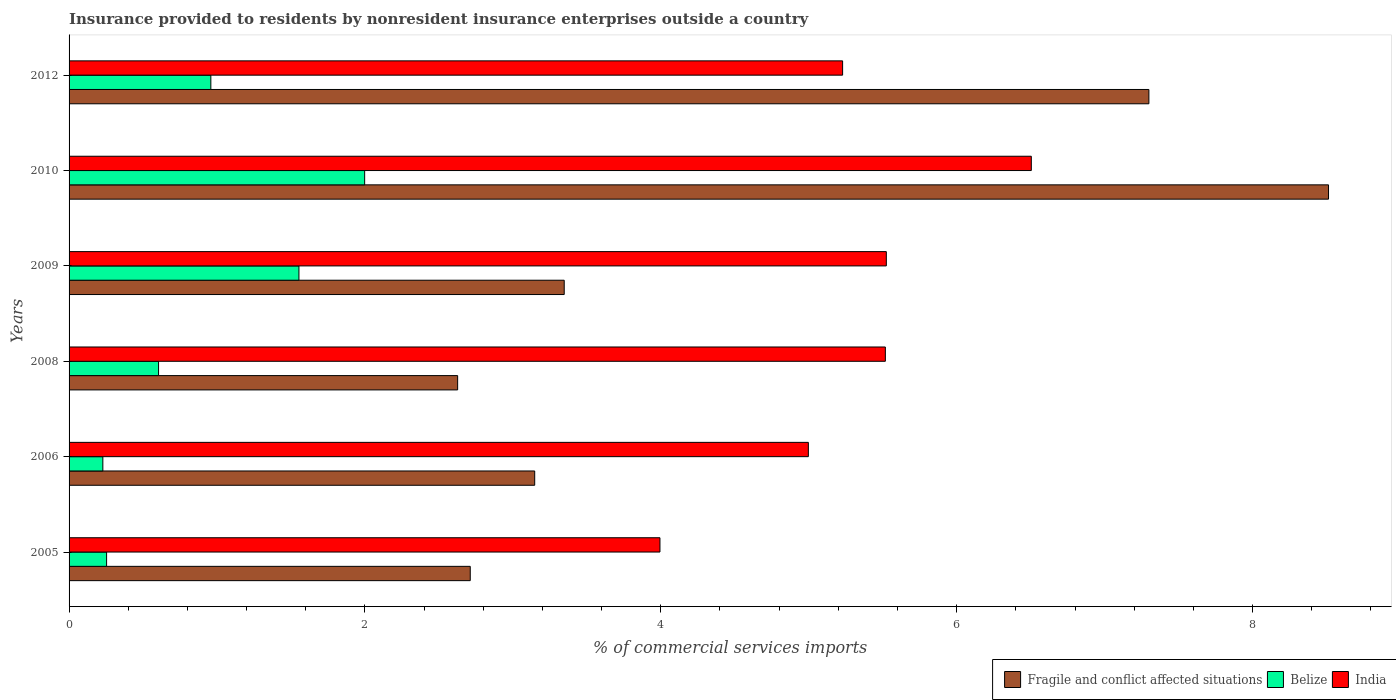How many different coloured bars are there?
Ensure brevity in your answer.  3. Are the number of bars per tick equal to the number of legend labels?
Provide a succinct answer. Yes. Are the number of bars on each tick of the Y-axis equal?
Give a very brief answer. Yes. How many bars are there on the 6th tick from the bottom?
Offer a very short reply. 3. In how many cases, is the number of bars for a given year not equal to the number of legend labels?
Your response must be concise. 0. What is the Insurance provided to residents in India in 2006?
Offer a terse response. 5. Across all years, what is the maximum Insurance provided to residents in Belize?
Provide a short and direct response. 2. Across all years, what is the minimum Insurance provided to residents in Belize?
Ensure brevity in your answer.  0.23. In which year was the Insurance provided to residents in Fragile and conflict affected situations minimum?
Offer a terse response. 2008. What is the total Insurance provided to residents in Belize in the graph?
Your response must be concise. 5.6. What is the difference between the Insurance provided to residents in Fragile and conflict affected situations in 2005 and that in 2012?
Ensure brevity in your answer.  -4.59. What is the difference between the Insurance provided to residents in Belize in 2006 and the Insurance provided to residents in India in 2012?
Make the answer very short. -5. What is the average Insurance provided to residents in India per year?
Provide a short and direct response. 5.29. In the year 2005, what is the difference between the Insurance provided to residents in Belize and Insurance provided to residents in Fragile and conflict affected situations?
Keep it short and to the point. -2.46. In how many years, is the Insurance provided to residents in India greater than 2 %?
Offer a very short reply. 6. What is the ratio of the Insurance provided to residents in India in 2005 to that in 2012?
Your response must be concise. 0.76. What is the difference between the highest and the second highest Insurance provided to residents in India?
Provide a succinct answer. 0.98. What is the difference between the highest and the lowest Insurance provided to residents in Belize?
Your answer should be very brief. 1.77. What does the 3rd bar from the top in 2006 represents?
Give a very brief answer. Fragile and conflict affected situations. What does the 3rd bar from the bottom in 2008 represents?
Provide a short and direct response. India. How many bars are there?
Offer a terse response. 18. Are all the bars in the graph horizontal?
Offer a terse response. Yes. What is the difference between two consecutive major ticks on the X-axis?
Give a very brief answer. 2. Where does the legend appear in the graph?
Give a very brief answer. Bottom right. How many legend labels are there?
Provide a succinct answer. 3. How are the legend labels stacked?
Offer a terse response. Horizontal. What is the title of the graph?
Your response must be concise. Insurance provided to residents by nonresident insurance enterprises outside a country. Does "Saudi Arabia" appear as one of the legend labels in the graph?
Your answer should be very brief. No. What is the label or title of the X-axis?
Keep it short and to the point. % of commercial services imports. What is the label or title of the Y-axis?
Ensure brevity in your answer.  Years. What is the % of commercial services imports of Fragile and conflict affected situations in 2005?
Ensure brevity in your answer.  2.71. What is the % of commercial services imports of Belize in 2005?
Offer a very short reply. 0.25. What is the % of commercial services imports in India in 2005?
Offer a very short reply. 3.99. What is the % of commercial services imports in Fragile and conflict affected situations in 2006?
Your answer should be very brief. 3.15. What is the % of commercial services imports of Belize in 2006?
Provide a succinct answer. 0.23. What is the % of commercial services imports of India in 2006?
Make the answer very short. 5. What is the % of commercial services imports of Fragile and conflict affected situations in 2008?
Keep it short and to the point. 2.63. What is the % of commercial services imports of Belize in 2008?
Offer a terse response. 0.6. What is the % of commercial services imports of India in 2008?
Ensure brevity in your answer.  5.52. What is the % of commercial services imports of Fragile and conflict affected situations in 2009?
Give a very brief answer. 3.35. What is the % of commercial services imports in Belize in 2009?
Your response must be concise. 1.55. What is the % of commercial services imports in India in 2009?
Keep it short and to the point. 5.52. What is the % of commercial services imports in Fragile and conflict affected situations in 2010?
Keep it short and to the point. 8.51. What is the % of commercial services imports in Belize in 2010?
Offer a very short reply. 2. What is the % of commercial services imports in India in 2010?
Keep it short and to the point. 6.5. What is the % of commercial services imports in Fragile and conflict affected situations in 2012?
Give a very brief answer. 7.3. What is the % of commercial services imports of Belize in 2012?
Your answer should be compact. 0.96. What is the % of commercial services imports in India in 2012?
Offer a very short reply. 5.23. Across all years, what is the maximum % of commercial services imports of Fragile and conflict affected situations?
Make the answer very short. 8.51. Across all years, what is the maximum % of commercial services imports in Belize?
Make the answer very short. 2. Across all years, what is the maximum % of commercial services imports of India?
Make the answer very short. 6.5. Across all years, what is the minimum % of commercial services imports of Fragile and conflict affected situations?
Give a very brief answer. 2.63. Across all years, what is the minimum % of commercial services imports in Belize?
Keep it short and to the point. 0.23. Across all years, what is the minimum % of commercial services imports of India?
Your answer should be very brief. 3.99. What is the total % of commercial services imports of Fragile and conflict affected situations in the graph?
Make the answer very short. 27.65. What is the total % of commercial services imports in Belize in the graph?
Your answer should be compact. 5.6. What is the total % of commercial services imports in India in the graph?
Provide a short and direct response. 31.77. What is the difference between the % of commercial services imports of Fragile and conflict affected situations in 2005 and that in 2006?
Your answer should be compact. -0.44. What is the difference between the % of commercial services imports of Belize in 2005 and that in 2006?
Ensure brevity in your answer.  0.03. What is the difference between the % of commercial services imports of India in 2005 and that in 2006?
Offer a very short reply. -1. What is the difference between the % of commercial services imports of Fragile and conflict affected situations in 2005 and that in 2008?
Your answer should be very brief. 0.09. What is the difference between the % of commercial services imports in Belize in 2005 and that in 2008?
Provide a short and direct response. -0.35. What is the difference between the % of commercial services imports in India in 2005 and that in 2008?
Offer a terse response. -1.52. What is the difference between the % of commercial services imports in Fragile and conflict affected situations in 2005 and that in 2009?
Your answer should be compact. -0.64. What is the difference between the % of commercial services imports in Belize in 2005 and that in 2009?
Provide a succinct answer. -1.3. What is the difference between the % of commercial services imports of India in 2005 and that in 2009?
Provide a short and direct response. -1.53. What is the difference between the % of commercial services imports in Fragile and conflict affected situations in 2005 and that in 2010?
Your answer should be compact. -5.8. What is the difference between the % of commercial services imports of Belize in 2005 and that in 2010?
Your answer should be compact. -1.74. What is the difference between the % of commercial services imports of India in 2005 and that in 2010?
Your answer should be compact. -2.51. What is the difference between the % of commercial services imports in Fragile and conflict affected situations in 2005 and that in 2012?
Offer a terse response. -4.59. What is the difference between the % of commercial services imports of Belize in 2005 and that in 2012?
Keep it short and to the point. -0.7. What is the difference between the % of commercial services imports in India in 2005 and that in 2012?
Keep it short and to the point. -1.23. What is the difference between the % of commercial services imports of Fragile and conflict affected situations in 2006 and that in 2008?
Keep it short and to the point. 0.52. What is the difference between the % of commercial services imports of Belize in 2006 and that in 2008?
Give a very brief answer. -0.38. What is the difference between the % of commercial services imports in India in 2006 and that in 2008?
Make the answer very short. -0.52. What is the difference between the % of commercial services imports in Fragile and conflict affected situations in 2006 and that in 2009?
Your answer should be compact. -0.2. What is the difference between the % of commercial services imports in Belize in 2006 and that in 2009?
Offer a terse response. -1.33. What is the difference between the % of commercial services imports of India in 2006 and that in 2009?
Offer a terse response. -0.53. What is the difference between the % of commercial services imports in Fragile and conflict affected situations in 2006 and that in 2010?
Your response must be concise. -5.37. What is the difference between the % of commercial services imports in Belize in 2006 and that in 2010?
Provide a short and direct response. -1.77. What is the difference between the % of commercial services imports in India in 2006 and that in 2010?
Your response must be concise. -1.51. What is the difference between the % of commercial services imports in Fragile and conflict affected situations in 2006 and that in 2012?
Your answer should be compact. -4.15. What is the difference between the % of commercial services imports of Belize in 2006 and that in 2012?
Offer a very short reply. -0.73. What is the difference between the % of commercial services imports of India in 2006 and that in 2012?
Your answer should be very brief. -0.23. What is the difference between the % of commercial services imports in Fragile and conflict affected situations in 2008 and that in 2009?
Offer a very short reply. -0.72. What is the difference between the % of commercial services imports in Belize in 2008 and that in 2009?
Your response must be concise. -0.95. What is the difference between the % of commercial services imports of India in 2008 and that in 2009?
Keep it short and to the point. -0.01. What is the difference between the % of commercial services imports of Fragile and conflict affected situations in 2008 and that in 2010?
Provide a succinct answer. -5.89. What is the difference between the % of commercial services imports of Belize in 2008 and that in 2010?
Provide a succinct answer. -1.39. What is the difference between the % of commercial services imports of India in 2008 and that in 2010?
Provide a short and direct response. -0.99. What is the difference between the % of commercial services imports of Fragile and conflict affected situations in 2008 and that in 2012?
Make the answer very short. -4.67. What is the difference between the % of commercial services imports in Belize in 2008 and that in 2012?
Ensure brevity in your answer.  -0.35. What is the difference between the % of commercial services imports in India in 2008 and that in 2012?
Provide a succinct answer. 0.29. What is the difference between the % of commercial services imports of Fragile and conflict affected situations in 2009 and that in 2010?
Your response must be concise. -5.17. What is the difference between the % of commercial services imports of Belize in 2009 and that in 2010?
Your response must be concise. -0.44. What is the difference between the % of commercial services imports of India in 2009 and that in 2010?
Offer a very short reply. -0.98. What is the difference between the % of commercial services imports of Fragile and conflict affected situations in 2009 and that in 2012?
Your answer should be very brief. -3.95. What is the difference between the % of commercial services imports in Belize in 2009 and that in 2012?
Your answer should be very brief. 0.6. What is the difference between the % of commercial services imports of India in 2009 and that in 2012?
Offer a terse response. 0.3. What is the difference between the % of commercial services imports of Fragile and conflict affected situations in 2010 and that in 2012?
Your response must be concise. 1.21. What is the difference between the % of commercial services imports in Belize in 2010 and that in 2012?
Ensure brevity in your answer.  1.04. What is the difference between the % of commercial services imports in India in 2010 and that in 2012?
Ensure brevity in your answer.  1.28. What is the difference between the % of commercial services imports of Fragile and conflict affected situations in 2005 and the % of commercial services imports of Belize in 2006?
Provide a short and direct response. 2.48. What is the difference between the % of commercial services imports in Fragile and conflict affected situations in 2005 and the % of commercial services imports in India in 2006?
Offer a very short reply. -2.29. What is the difference between the % of commercial services imports in Belize in 2005 and the % of commercial services imports in India in 2006?
Your response must be concise. -4.74. What is the difference between the % of commercial services imports of Fragile and conflict affected situations in 2005 and the % of commercial services imports of Belize in 2008?
Make the answer very short. 2.11. What is the difference between the % of commercial services imports in Fragile and conflict affected situations in 2005 and the % of commercial services imports in India in 2008?
Provide a short and direct response. -2.81. What is the difference between the % of commercial services imports of Belize in 2005 and the % of commercial services imports of India in 2008?
Your answer should be compact. -5.26. What is the difference between the % of commercial services imports in Fragile and conflict affected situations in 2005 and the % of commercial services imports in Belize in 2009?
Keep it short and to the point. 1.16. What is the difference between the % of commercial services imports of Fragile and conflict affected situations in 2005 and the % of commercial services imports of India in 2009?
Keep it short and to the point. -2.81. What is the difference between the % of commercial services imports in Belize in 2005 and the % of commercial services imports in India in 2009?
Make the answer very short. -5.27. What is the difference between the % of commercial services imports in Fragile and conflict affected situations in 2005 and the % of commercial services imports in Belize in 2010?
Ensure brevity in your answer.  0.71. What is the difference between the % of commercial services imports of Fragile and conflict affected situations in 2005 and the % of commercial services imports of India in 2010?
Provide a succinct answer. -3.79. What is the difference between the % of commercial services imports of Belize in 2005 and the % of commercial services imports of India in 2010?
Offer a very short reply. -6.25. What is the difference between the % of commercial services imports of Fragile and conflict affected situations in 2005 and the % of commercial services imports of Belize in 2012?
Offer a very short reply. 1.75. What is the difference between the % of commercial services imports in Fragile and conflict affected situations in 2005 and the % of commercial services imports in India in 2012?
Keep it short and to the point. -2.52. What is the difference between the % of commercial services imports of Belize in 2005 and the % of commercial services imports of India in 2012?
Make the answer very short. -4.98. What is the difference between the % of commercial services imports in Fragile and conflict affected situations in 2006 and the % of commercial services imports in Belize in 2008?
Your answer should be compact. 2.54. What is the difference between the % of commercial services imports in Fragile and conflict affected situations in 2006 and the % of commercial services imports in India in 2008?
Your answer should be compact. -2.37. What is the difference between the % of commercial services imports of Belize in 2006 and the % of commercial services imports of India in 2008?
Offer a terse response. -5.29. What is the difference between the % of commercial services imports in Fragile and conflict affected situations in 2006 and the % of commercial services imports in Belize in 2009?
Your answer should be compact. 1.59. What is the difference between the % of commercial services imports in Fragile and conflict affected situations in 2006 and the % of commercial services imports in India in 2009?
Your answer should be very brief. -2.38. What is the difference between the % of commercial services imports in Belize in 2006 and the % of commercial services imports in India in 2009?
Give a very brief answer. -5.3. What is the difference between the % of commercial services imports of Fragile and conflict affected situations in 2006 and the % of commercial services imports of Belize in 2010?
Ensure brevity in your answer.  1.15. What is the difference between the % of commercial services imports of Fragile and conflict affected situations in 2006 and the % of commercial services imports of India in 2010?
Provide a short and direct response. -3.36. What is the difference between the % of commercial services imports of Belize in 2006 and the % of commercial services imports of India in 2010?
Your response must be concise. -6.28. What is the difference between the % of commercial services imports of Fragile and conflict affected situations in 2006 and the % of commercial services imports of Belize in 2012?
Ensure brevity in your answer.  2.19. What is the difference between the % of commercial services imports in Fragile and conflict affected situations in 2006 and the % of commercial services imports in India in 2012?
Provide a succinct answer. -2.08. What is the difference between the % of commercial services imports in Belize in 2006 and the % of commercial services imports in India in 2012?
Offer a very short reply. -5. What is the difference between the % of commercial services imports in Fragile and conflict affected situations in 2008 and the % of commercial services imports in Belize in 2009?
Offer a terse response. 1.07. What is the difference between the % of commercial services imports of Fragile and conflict affected situations in 2008 and the % of commercial services imports of India in 2009?
Provide a succinct answer. -2.9. What is the difference between the % of commercial services imports in Belize in 2008 and the % of commercial services imports in India in 2009?
Offer a very short reply. -4.92. What is the difference between the % of commercial services imports in Fragile and conflict affected situations in 2008 and the % of commercial services imports in Belize in 2010?
Make the answer very short. 0.63. What is the difference between the % of commercial services imports of Fragile and conflict affected situations in 2008 and the % of commercial services imports of India in 2010?
Provide a short and direct response. -3.88. What is the difference between the % of commercial services imports of Belize in 2008 and the % of commercial services imports of India in 2010?
Your response must be concise. -5.9. What is the difference between the % of commercial services imports in Fragile and conflict affected situations in 2008 and the % of commercial services imports in Belize in 2012?
Provide a succinct answer. 1.67. What is the difference between the % of commercial services imports of Fragile and conflict affected situations in 2008 and the % of commercial services imports of India in 2012?
Keep it short and to the point. -2.6. What is the difference between the % of commercial services imports in Belize in 2008 and the % of commercial services imports in India in 2012?
Ensure brevity in your answer.  -4.62. What is the difference between the % of commercial services imports of Fragile and conflict affected situations in 2009 and the % of commercial services imports of Belize in 2010?
Your answer should be compact. 1.35. What is the difference between the % of commercial services imports in Fragile and conflict affected situations in 2009 and the % of commercial services imports in India in 2010?
Your response must be concise. -3.16. What is the difference between the % of commercial services imports of Belize in 2009 and the % of commercial services imports of India in 2010?
Your answer should be very brief. -4.95. What is the difference between the % of commercial services imports of Fragile and conflict affected situations in 2009 and the % of commercial services imports of Belize in 2012?
Keep it short and to the point. 2.39. What is the difference between the % of commercial services imports of Fragile and conflict affected situations in 2009 and the % of commercial services imports of India in 2012?
Your answer should be compact. -1.88. What is the difference between the % of commercial services imports of Belize in 2009 and the % of commercial services imports of India in 2012?
Provide a succinct answer. -3.68. What is the difference between the % of commercial services imports of Fragile and conflict affected situations in 2010 and the % of commercial services imports of Belize in 2012?
Offer a terse response. 7.56. What is the difference between the % of commercial services imports of Fragile and conflict affected situations in 2010 and the % of commercial services imports of India in 2012?
Make the answer very short. 3.28. What is the difference between the % of commercial services imports in Belize in 2010 and the % of commercial services imports in India in 2012?
Your response must be concise. -3.23. What is the average % of commercial services imports of Fragile and conflict affected situations per year?
Offer a very short reply. 4.61. What is the average % of commercial services imports in Belize per year?
Provide a succinct answer. 0.93. What is the average % of commercial services imports in India per year?
Offer a terse response. 5.29. In the year 2005, what is the difference between the % of commercial services imports in Fragile and conflict affected situations and % of commercial services imports in Belize?
Ensure brevity in your answer.  2.46. In the year 2005, what is the difference between the % of commercial services imports of Fragile and conflict affected situations and % of commercial services imports of India?
Keep it short and to the point. -1.28. In the year 2005, what is the difference between the % of commercial services imports of Belize and % of commercial services imports of India?
Offer a very short reply. -3.74. In the year 2006, what is the difference between the % of commercial services imports of Fragile and conflict affected situations and % of commercial services imports of Belize?
Your answer should be compact. 2.92. In the year 2006, what is the difference between the % of commercial services imports of Fragile and conflict affected situations and % of commercial services imports of India?
Offer a very short reply. -1.85. In the year 2006, what is the difference between the % of commercial services imports in Belize and % of commercial services imports in India?
Make the answer very short. -4.77. In the year 2008, what is the difference between the % of commercial services imports of Fragile and conflict affected situations and % of commercial services imports of Belize?
Provide a short and direct response. 2.02. In the year 2008, what is the difference between the % of commercial services imports in Fragile and conflict affected situations and % of commercial services imports in India?
Your answer should be very brief. -2.89. In the year 2008, what is the difference between the % of commercial services imports of Belize and % of commercial services imports of India?
Your answer should be very brief. -4.91. In the year 2009, what is the difference between the % of commercial services imports in Fragile and conflict affected situations and % of commercial services imports in Belize?
Make the answer very short. 1.79. In the year 2009, what is the difference between the % of commercial services imports in Fragile and conflict affected situations and % of commercial services imports in India?
Give a very brief answer. -2.18. In the year 2009, what is the difference between the % of commercial services imports in Belize and % of commercial services imports in India?
Your answer should be very brief. -3.97. In the year 2010, what is the difference between the % of commercial services imports in Fragile and conflict affected situations and % of commercial services imports in Belize?
Make the answer very short. 6.52. In the year 2010, what is the difference between the % of commercial services imports in Fragile and conflict affected situations and % of commercial services imports in India?
Your answer should be compact. 2.01. In the year 2010, what is the difference between the % of commercial services imports of Belize and % of commercial services imports of India?
Your answer should be very brief. -4.51. In the year 2012, what is the difference between the % of commercial services imports of Fragile and conflict affected situations and % of commercial services imports of Belize?
Provide a succinct answer. 6.34. In the year 2012, what is the difference between the % of commercial services imports of Fragile and conflict affected situations and % of commercial services imports of India?
Ensure brevity in your answer.  2.07. In the year 2012, what is the difference between the % of commercial services imports in Belize and % of commercial services imports in India?
Your response must be concise. -4.27. What is the ratio of the % of commercial services imports in Fragile and conflict affected situations in 2005 to that in 2006?
Ensure brevity in your answer.  0.86. What is the ratio of the % of commercial services imports of Belize in 2005 to that in 2006?
Keep it short and to the point. 1.11. What is the ratio of the % of commercial services imports of India in 2005 to that in 2006?
Provide a succinct answer. 0.8. What is the ratio of the % of commercial services imports in Fragile and conflict affected situations in 2005 to that in 2008?
Give a very brief answer. 1.03. What is the ratio of the % of commercial services imports in Belize in 2005 to that in 2008?
Your answer should be very brief. 0.42. What is the ratio of the % of commercial services imports of India in 2005 to that in 2008?
Make the answer very short. 0.72. What is the ratio of the % of commercial services imports of Fragile and conflict affected situations in 2005 to that in 2009?
Your response must be concise. 0.81. What is the ratio of the % of commercial services imports in Belize in 2005 to that in 2009?
Your answer should be compact. 0.16. What is the ratio of the % of commercial services imports of India in 2005 to that in 2009?
Keep it short and to the point. 0.72. What is the ratio of the % of commercial services imports of Fragile and conflict affected situations in 2005 to that in 2010?
Your answer should be very brief. 0.32. What is the ratio of the % of commercial services imports of Belize in 2005 to that in 2010?
Offer a very short reply. 0.13. What is the ratio of the % of commercial services imports of India in 2005 to that in 2010?
Your answer should be very brief. 0.61. What is the ratio of the % of commercial services imports of Fragile and conflict affected situations in 2005 to that in 2012?
Your response must be concise. 0.37. What is the ratio of the % of commercial services imports in Belize in 2005 to that in 2012?
Offer a terse response. 0.26. What is the ratio of the % of commercial services imports in India in 2005 to that in 2012?
Your answer should be very brief. 0.76. What is the ratio of the % of commercial services imports of Fragile and conflict affected situations in 2006 to that in 2008?
Make the answer very short. 1.2. What is the ratio of the % of commercial services imports in Belize in 2006 to that in 2008?
Your response must be concise. 0.38. What is the ratio of the % of commercial services imports of India in 2006 to that in 2008?
Provide a short and direct response. 0.91. What is the ratio of the % of commercial services imports of Fragile and conflict affected situations in 2006 to that in 2009?
Offer a terse response. 0.94. What is the ratio of the % of commercial services imports of Belize in 2006 to that in 2009?
Give a very brief answer. 0.15. What is the ratio of the % of commercial services imports of India in 2006 to that in 2009?
Provide a succinct answer. 0.9. What is the ratio of the % of commercial services imports of Fragile and conflict affected situations in 2006 to that in 2010?
Your response must be concise. 0.37. What is the ratio of the % of commercial services imports of Belize in 2006 to that in 2010?
Offer a very short reply. 0.11. What is the ratio of the % of commercial services imports of India in 2006 to that in 2010?
Give a very brief answer. 0.77. What is the ratio of the % of commercial services imports of Fragile and conflict affected situations in 2006 to that in 2012?
Offer a terse response. 0.43. What is the ratio of the % of commercial services imports in Belize in 2006 to that in 2012?
Your answer should be very brief. 0.24. What is the ratio of the % of commercial services imports in India in 2006 to that in 2012?
Your response must be concise. 0.96. What is the ratio of the % of commercial services imports in Fragile and conflict affected situations in 2008 to that in 2009?
Give a very brief answer. 0.78. What is the ratio of the % of commercial services imports of Belize in 2008 to that in 2009?
Give a very brief answer. 0.39. What is the ratio of the % of commercial services imports of India in 2008 to that in 2009?
Make the answer very short. 1. What is the ratio of the % of commercial services imports in Fragile and conflict affected situations in 2008 to that in 2010?
Your response must be concise. 0.31. What is the ratio of the % of commercial services imports in Belize in 2008 to that in 2010?
Your answer should be compact. 0.3. What is the ratio of the % of commercial services imports in India in 2008 to that in 2010?
Offer a very short reply. 0.85. What is the ratio of the % of commercial services imports of Fragile and conflict affected situations in 2008 to that in 2012?
Your response must be concise. 0.36. What is the ratio of the % of commercial services imports of Belize in 2008 to that in 2012?
Keep it short and to the point. 0.63. What is the ratio of the % of commercial services imports of India in 2008 to that in 2012?
Keep it short and to the point. 1.06. What is the ratio of the % of commercial services imports of Fragile and conflict affected situations in 2009 to that in 2010?
Ensure brevity in your answer.  0.39. What is the ratio of the % of commercial services imports in Belize in 2009 to that in 2010?
Provide a succinct answer. 0.78. What is the ratio of the % of commercial services imports in India in 2009 to that in 2010?
Provide a short and direct response. 0.85. What is the ratio of the % of commercial services imports of Fragile and conflict affected situations in 2009 to that in 2012?
Your answer should be compact. 0.46. What is the ratio of the % of commercial services imports in Belize in 2009 to that in 2012?
Give a very brief answer. 1.62. What is the ratio of the % of commercial services imports in India in 2009 to that in 2012?
Provide a short and direct response. 1.06. What is the ratio of the % of commercial services imports in Fragile and conflict affected situations in 2010 to that in 2012?
Provide a short and direct response. 1.17. What is the ratio of the % of commercial services imports of Belize in 2010 to that in 2012?
Make the answer very short. 2.08. What is the ratio of the % of commercial services imports in India in 2010 to that in 2012?
Provide a succinct answer. 1.24. What is the difference between the highest and the second highest % of commercial services imports of Fragile and conflict affected situations?
Keep it short and to the point. 1.21. What is the difference between the highest and the second highest % of commercial services imports in Belize?
Provide a short and direct response. 0.44. What is the difference between the highest and the lowest % of commercial services imports of Fragile and conflict affected situations?
Offer a very short reply. 5.89. What is the difference between the highest and the lowest % of commercial services imports in Belize?
Offer a very short reply. 1.77. What is the difference between the highest and the lowest % of commercial services imports of India?
Provide a short and direct response. 2.51. 